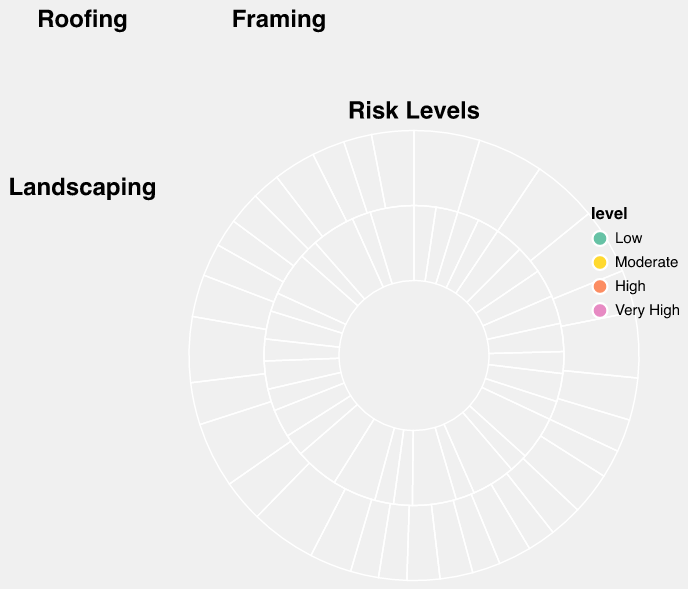What is the title of the subplot that has data for framing activities? The title of the subplot is provided at the top of each subplot. For framing activities, it's clearly labeled as "Framing".
Answer: Framing Which activity has the highest total hours worked in July? From the 'Hours' data for July in each subplot, the activity with the highest value is Framing with 45 hours.
Answer: Framing How does the high temperature risk for roofing compare in June and December? Examining the "High Temp Risk" for Roofing in both June and December, June has a "Very High" risk, whereas December has a "Moderate" risk.
Answer: June has a higher risk What is the total number of hours worked for landscaping in the summer months (June, July, and August)? Adding the hours for landscaping in June (30), July (35), and August (32), we get 30 + 35 + 32 = 97 hours.
Answer: 97 hours What is the difference in hours worked on framing between January and July? The hours worked on framing in January is 20 hours, and in July is 45 hours. So the difference is 45 - 20 = 25 hours.
Answer: 25 hours For which month and activity combination is air quality risk the highest? According to the subplots, the air quality risk is highest consistently in the months of June, July, August, and December for all the activities (roofing, framing, and landscaping) where it is indicated as "High". July-Framing stands out with the highest hours.
Answer: July-Framing Compare the number of hours worked in roofing and framing during the month of March. The hours worked in roofing for March is 20 hours, while framing is 25 hours. Framing has 5 more hours compared to roofing.
Answer: Framing has 5 more hours Which activity has the most consistent hours worked throughout the year? Observing each activity's hours throughout the months, landscaping appears most consistent, generally fluctuating between 10 to 35 hours, without large variations.
Answer: Landscaping From the Risk Levels subplot, which risk type and level combination has the highest count? The Risk Levels subplot shows different risk categories with counts for each level. The combination of 'High Temp Risk' with 'Very High' risk level has the highest count visible in the purple color section.
Answer: 'Very High' High Temp Risk 